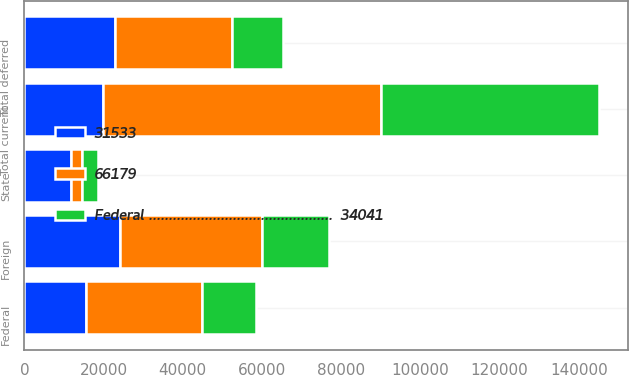Convert chart. <chart><loc_0><loc_0><loc_500><loc_500><stacked_bar_chart><ecel><fcel>State<fcel>Foreign<fcel>Total current<fcel>Federal<fcel>Total deferred<nl><fcel>Federal ..............................................  34041<fcel>4020<fcel>16947<fcel>55008<fcel>13709<fcel>12811<nl><fcel>66179<fcel>2806<fcel>35830<fcel>70169<fcel>29447<fcel>29535<nl><fcel>31533<fcel>11859<fcel>24070<fcel>19957.5<fcel>15439<fcel>22968<nl></chart> 